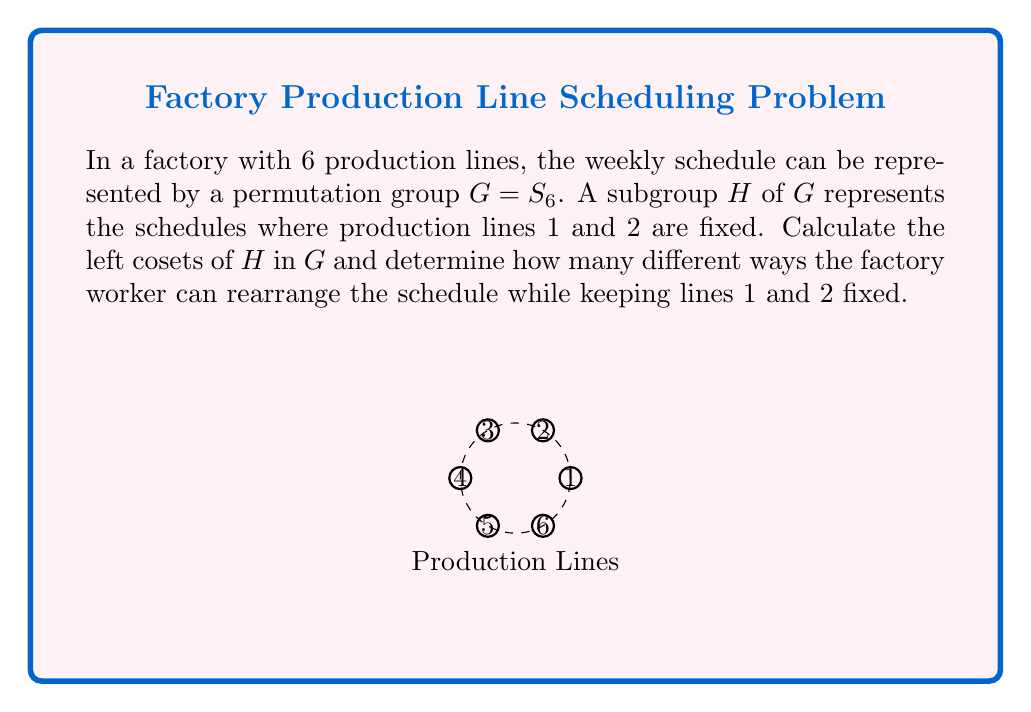Give your solution to this math problem. Let's approach this step-by-step:

1) First, we need to identify the subgroup $H$. Since lines 1 and 2 are fixed, $H$ is isomorphic to $S_4$, permuting the remaining 4 lines.

2) The order of $H$ is $|H| = 4! = 24$.

3) The order of $G$ is $|G| = 6! = 720$.

4) By Lagrange's theorem, the number of left cosets of $H$ in $G$ is equal to the index of $H$ in $G$:

   $$[G:H] = \frac{|G|}{|H|} = \frac{720}{24} = 30$$

5) Each coset represents a different way to arrange lines 1 and 2 relative to the others. We can think of this as choosing 2 positions out of 6 for lines 1 and 2, which can be done in $\binom{6}{2} = 15$ ways.

6) However, for each of these 15 arrangements, we have 2 possibilities: either line 1 is in the lower-numbered position and line 2 in the higher, or vice versa.

7) Therefore, the total number of cosets (and thus the number of ways to rearrange the schedule while keeping lines 1 and 2 fixed relative to each other) is $15 \times 2 = 30$.

This confirms our calculation using Lagrange's theorem.
Answer: 30 cosets, representing 30 different schedule arrangements 